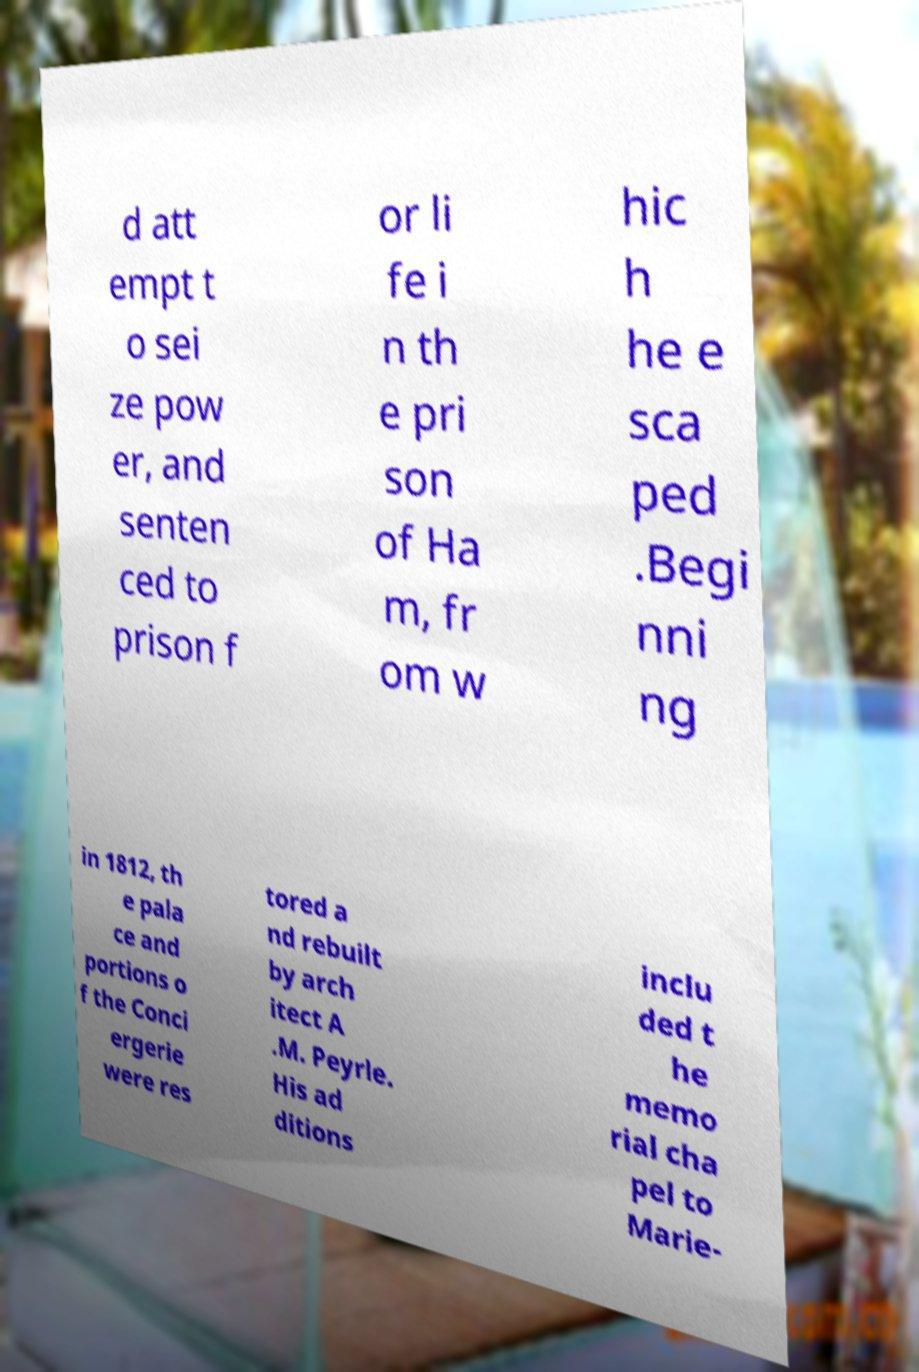Please identify and transcribe the text found in this image. d att empt t o sei ze pow er, and senten ced to prison f or li fe i n th e pri son of Ha m, fr om w hic h he e sca ped .Begi nni ng in 1812, th e pala ce and portions o f the Conci ergerie were res tored a nd rebuilt by arch itect A .M. Peyrle. His ad ditions inclu ded t he memo rial cha pel to Marie- 